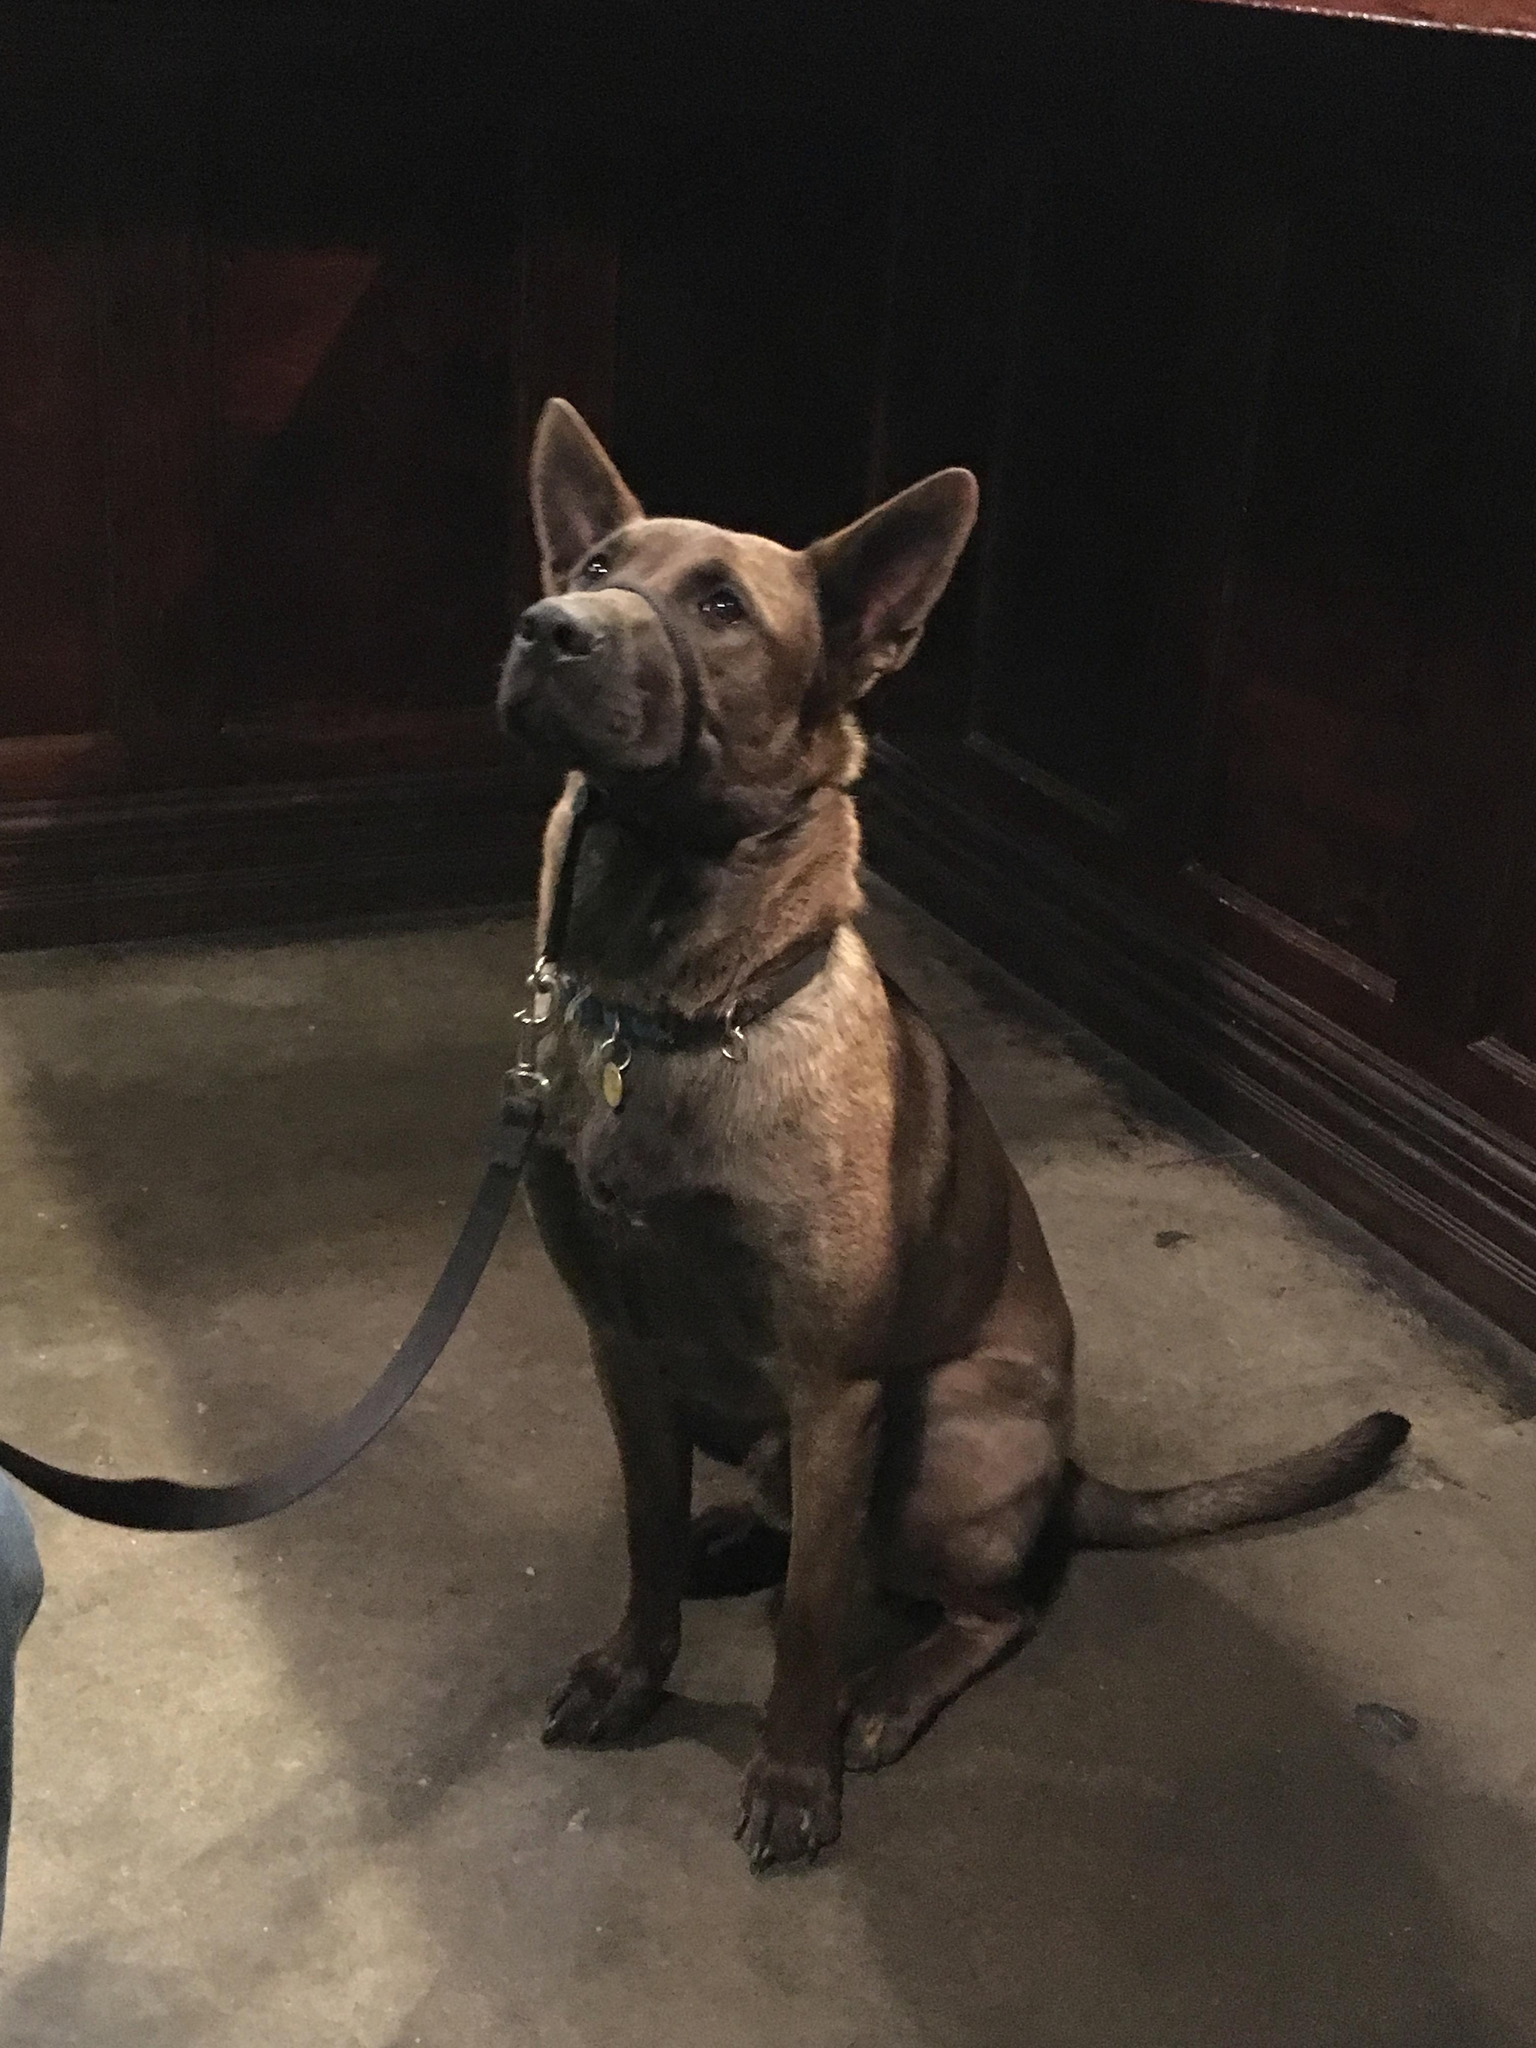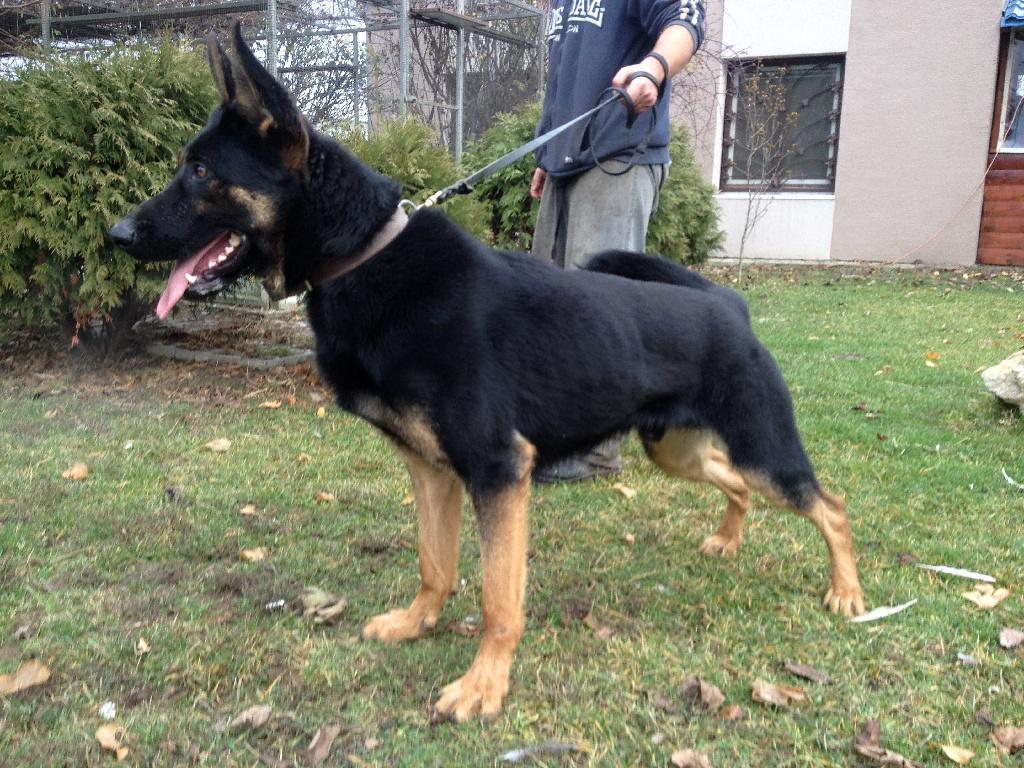The first image is the image on the left, the second image is the image on the right. Assess this claim about the two images: "At least one of the dogs is actively moving by running, jumping, or walking.". Correct or not? Answer yes or no. No. 